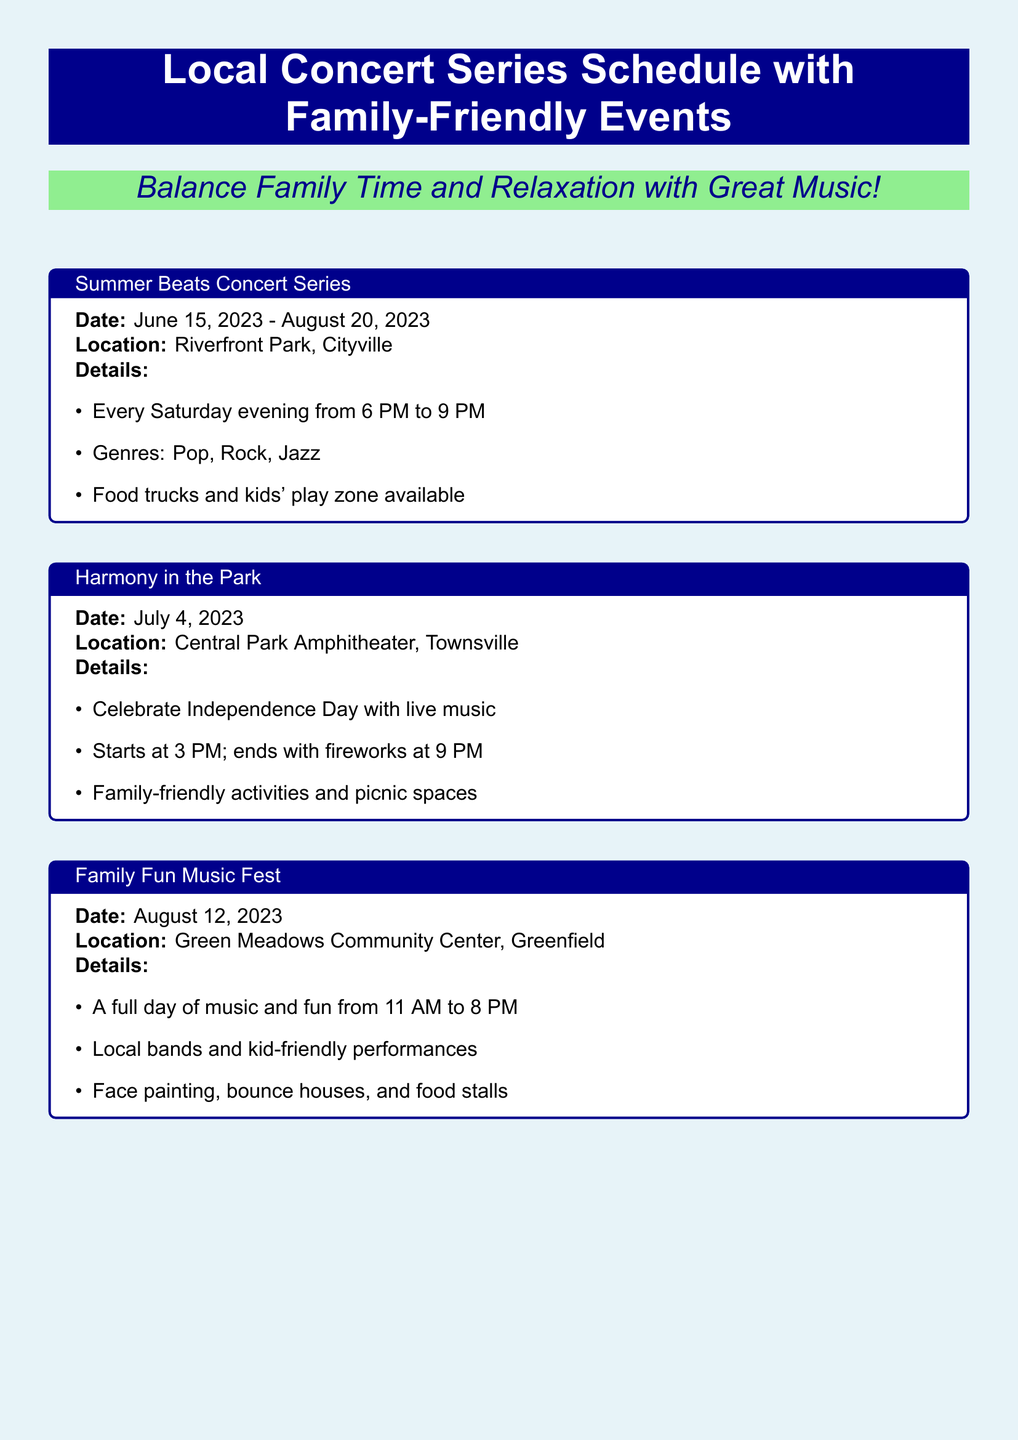What is the name of the concert series? The name of the concert series is mentioned prominently at the top of the document.
Answer: Local Concert Series Schedule with Family-Friendly Events What is the location of the Summer Beats Concert Series? This information is provided within the details of the Summer Beats Concert Series section.
Answer: Riverfront Park, Cityville On which date does the Harmony in the Park event take place? The specific date is provided in bold within the Harmony in the Park box.
Answer: July 4, 2023 What type of activities are available for kids at the Jazz Under the Stars event? The details mention the activities specifically for children in the same section.
Answer: Crafts and games How many events are listed in the document? The number of events can be counted from the various concert sections presented.
Answer: Four What time does the Family Fun Music Fest start? This information is clearly stated in the Family Fun Music Fest section.
Answer: 11 AM Which event includes fireworks? Looking through the details provided will indicate which event has fireworks as part of its activities.
Answer: Harmony in the Park What is the last date for the Summer Beats Concert Series? This date can be found at the end of the Summer Beats Concert Series details.
Answer: August 20, 2023 